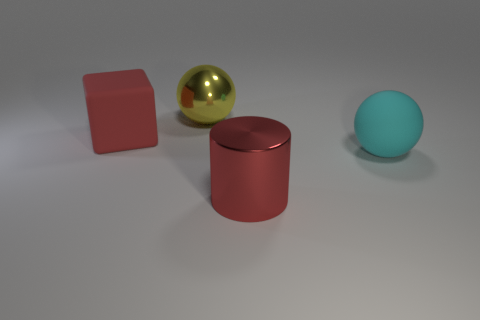There is a thing that is the same color as the large cube; what is it made of?
Your response must be concise. Metal. What number of big objects are the same color as the cylinder?
Your answer should be compact. 1. Does the large matte block have the same color as the metal object on the right side of the big shiny sphere?
Offer a very short reply. Yes. There is a yellow thing that is the same shape as the large cyan matte thing; what is its material?
Provide a succinct answer. Metal. There is a cyan matte thing that is to the right of the red thing on the left side of the large red cylinder; how many large metal objects are on the right side of it?
Give a very brief answer. 0. Are there any other things that have the same color as the big metallic ball?
Offer a terse response. No. What number of things are behind the red metal object and to the right of the big yellow shiny sphere?
Make the answer very short. 1. How many things are rubber objects that are in front of the large red cube or big matte objects?
Your answer should be very brief. 2. What is the big ball on the right side of the large yellow ball made of?
Your answer should be very brief. Rubber. What material is the yellow object?
Keep it short and to the point. Metal. 